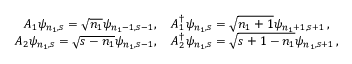Convert formula to latex. <formula><loc_0><loc_0><loc_500><loc_500>\begin{array} { r l } { A _ { 1 } \psi _ { n _ { 1 } , s } = \sqrt { n _ { 1 } } \psi _ { n _ { 1 } - 1 , s - 1 } , } & { A _ { 1 } ^ { \dagger } \psi _ { n _ { 1 } , s } = \sqrt { n _ { 1 } + 1 } \psi _ { n _ { 1 } + 1 , s + 1 } , } \\ { A _ { 2 } \psi _ { n _ { 1 } , s } = \sqrt { s - n _ { 1 } } \psi _ { n _ { 1 } , s - 1 } , } & { A _ { 2 } ^ { \dagger } \psi _ { n _ { 1 } , s } = \sqrt { s + 1 - n _ { 1 } } \psi _ { n _ { 1 } , s + 1 } , } \end{array}</formula> 